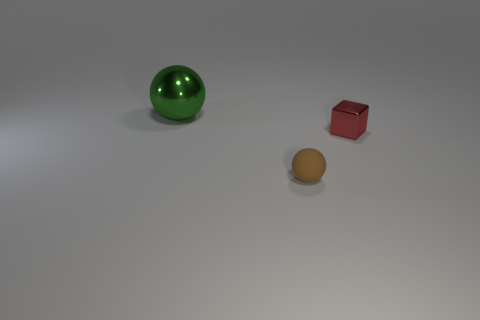Add 2 tiny yellow metallic balls. How many objects exist? 5 Subtract all spheres. How many objects are left? 1 Subtract all large metal blocks. Subtract all red metallic cubes. How many objects are left? 2 Add 3 small red metal things. How many small red metal things are left? 4 Add 1 blocks. How many blocks exist? 2 Subtract 0 yellow balls. How many objects are left? 3 